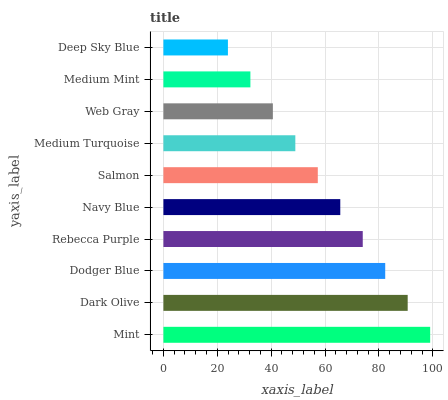Is Deep Sky Blue the minimum?
Answer yes or no. Yes. Is Mint the maximum?
Answer yes or no. Yes. Is Dark Olive the minimum?
Answer yes or no. No. Is Dark Olive the maximum?
Answer yes or no. No. Is Mint greater than Dark Olive?
Answer yes or no. Yes. Is Dark Olive less than Mint?
Answer yes or no. Yes. Is Dark Olive greater than Mint?
Answer yes or no. No. Is Mint less than Dark Olive?
Answer yes or no. No. Is Navy Blue the high median?
Answer yes or no. Yes. Is Salmon the low median?
Answer yes or no. Yes. Is Mint the high median?
Answer yes or no. No. Is Medium Turquoise the low median?
Answer yes or no. No. 